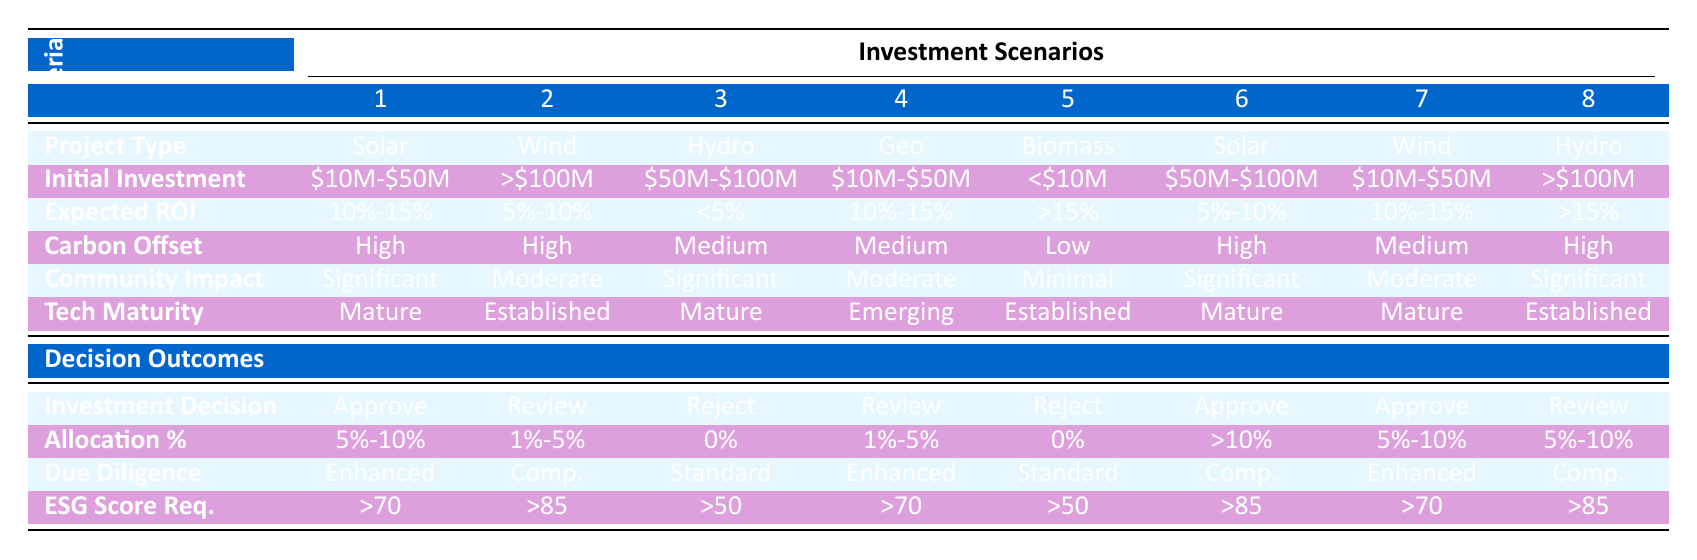What is the investment decision for Solar projects with an initial investment between $10M and $50M? According to the rules for Solar projects with an initial investment of $10M - $50M, the investment decision is to "Approve."
Answer: Approve Which renewable energy project has the highest Allocation Percentage among the shown options? The table indicates that the highest Allocation Percentage is "> 10%" related to a Solar project with an initial investment of $50M - $100M.
Answer: > 10% What is the due diligence level required for Wind projects with an initial investment of over $100M? The rules specify that for Wind projects with an initial investment of over $100M, the due diligence level required is "Comprehensive."
Answer: Comprehensive Is there any investment decision that results in a "Reject" outcome? A review of the table reveals that there are two instances where the investment decision results in "Reject": one for Biomass and one for Hydroelectric projects.
Answer: Yes Calculate the average expected ROI for projects classified as "Approve." The expected ROIs for approved projects are: 10%-15%, 5%-10%, and 10%-15%. To calculate the average, convert these percentages into decimals: 0.125, 0.075, and 0.125. The sum is 0.125 + 0.075 + 0.125 = 0.325, and dividing by 3 gives an average of approximately 0.108, which corresponds to 10%-15%.
Answer: Approximately 10%-15% 